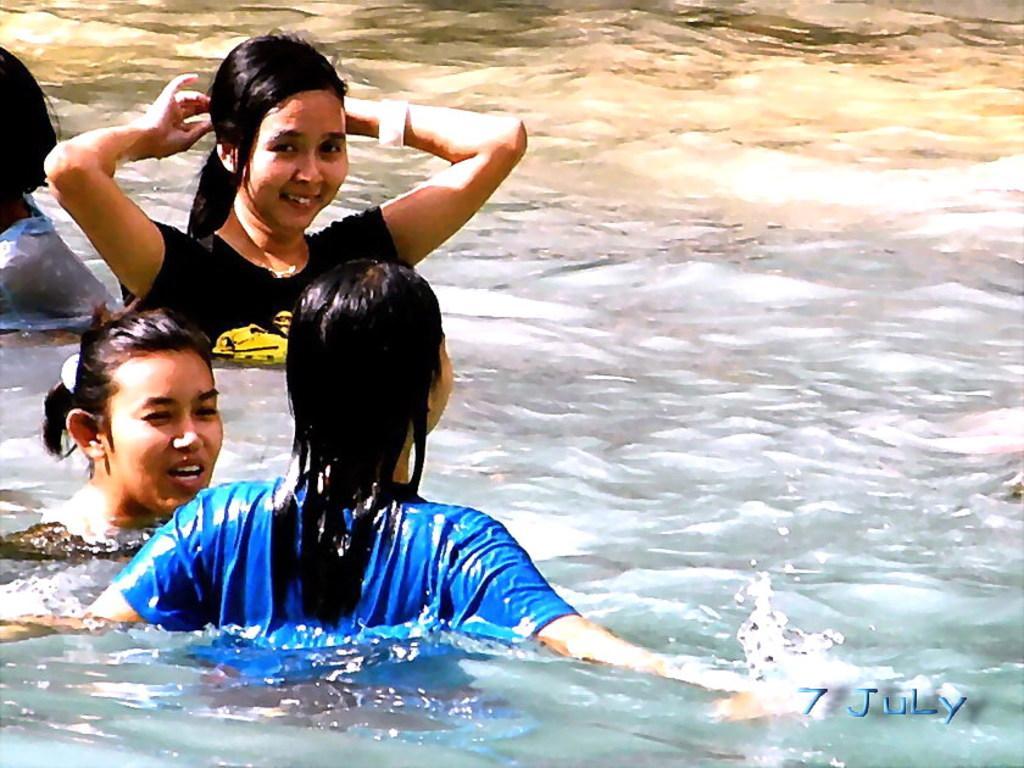In one or two sentences, can you explain what this image depicts? On the left side of the image, we can see few people are in the water. Here a woman is smiling. Right side bottom, we can see a watermark in the image. 